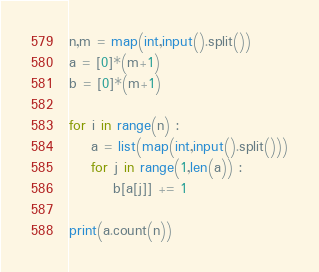<code> <loc_0><loc_0><loc_500><loc_500><_Python_>n,m = map(int,input().split())
a = [0]*(m+1)
b = [0]*(m+1)

for i in range(n) :
    a = list(map(int,input().split()))
    for j in range(1,len(a)) :
        b[a[j]] += 1

print(a.count(n))</code> 